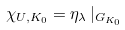Convert formula to latex. <formula><loc_0><loc_0><loc_500><loc_500>\chi _ { U , K _ { 0 } } = \eta _ { \lambda } \, | _ { G _ { K _ { 0 } } }</formula> 